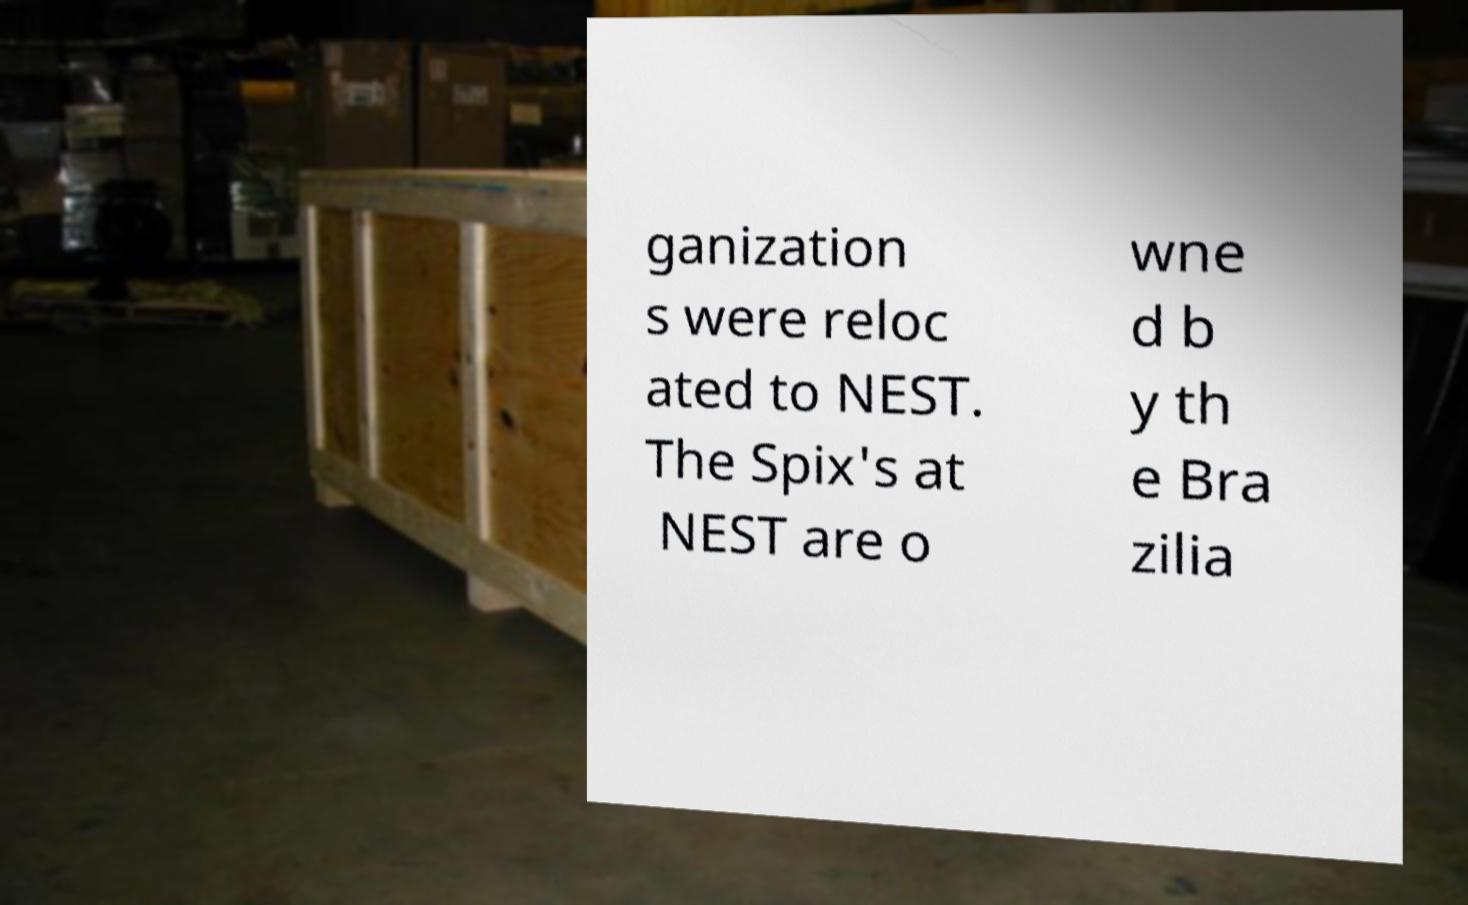For documentation purposes, I need the text within this image transcribed. Could you provide that? ganization s were reloc ated to NEST. The Spix's at NEST are o wne d b y th e Bra zilia 